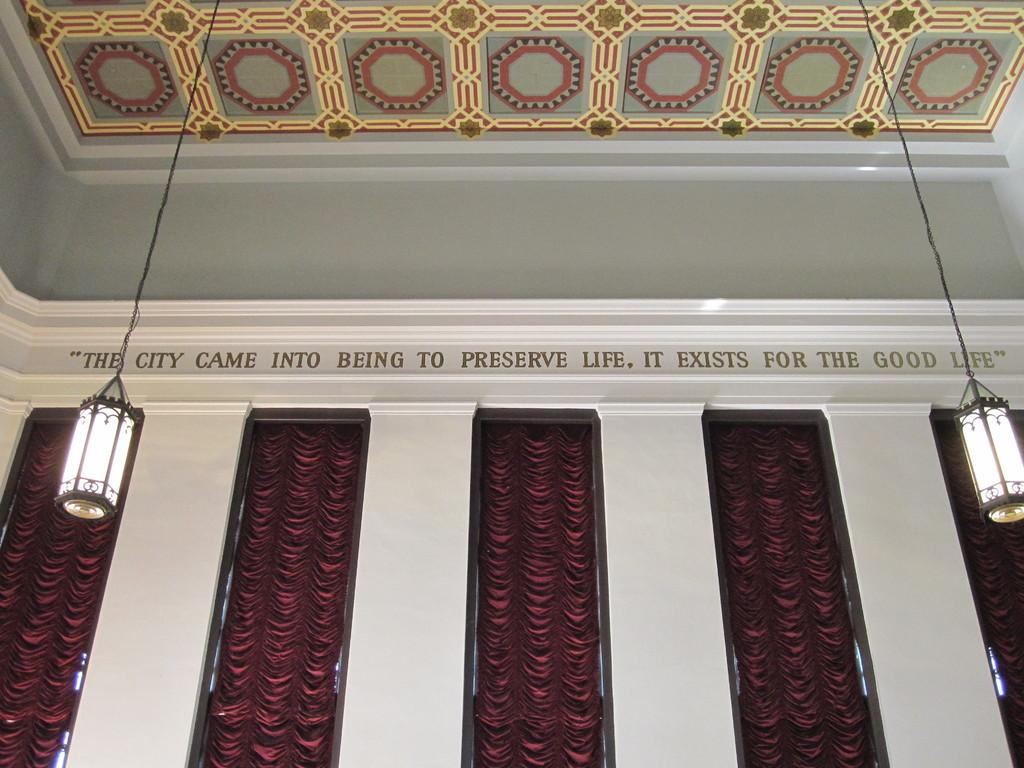What type of view is shown in the image? The image is an inner view of a building. What can be seen on the walls in the image? There is a wall and some text on a wall in the image. What type of window treatment is present in the image? There are windows with curtains in the image. How are the lamps positioned in the image? There are two lamps hanged with a wire in the image. What type of shelf can be seen on the wall in the image? There is no shelf present on the wall in the image. What language is written on the text in the image? The language of the text cannot be determined from the image alone, as it is not legible. 